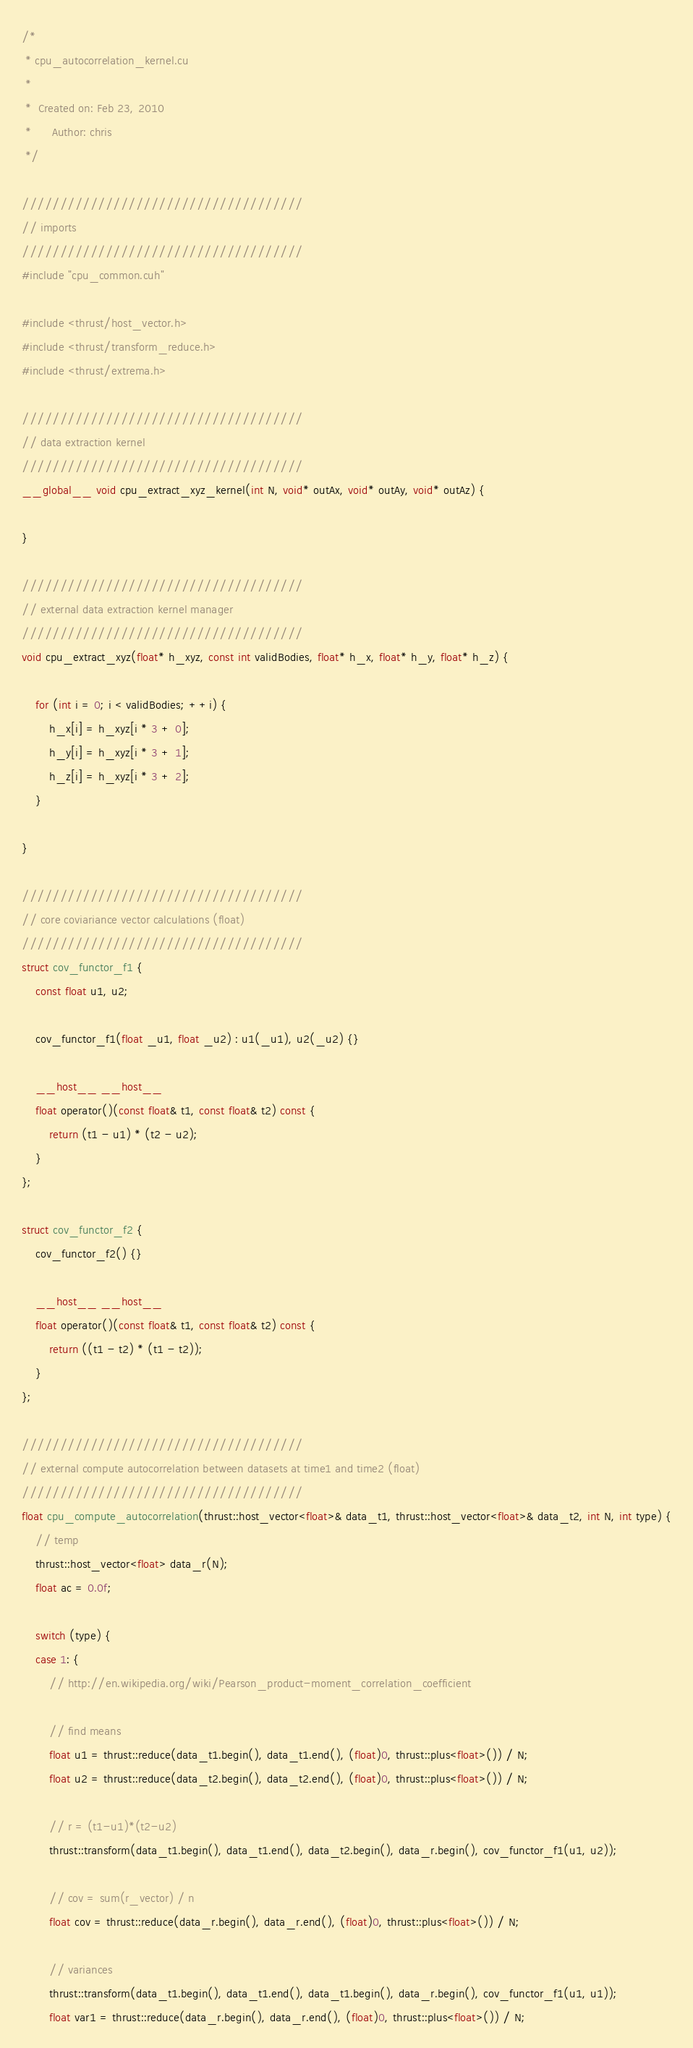Convert code to text. <code><loc_0><loc_0><loc_500><loc_500><_Cuda_>/*
 * cpu_autocorrelation_kernel.cu
 *
 *  Created on: Feb 23, 2010
 *      Author: chris
 */

/////////////////////////////////////
// imports
/////////////////////////////////////
#include "cpu_common.cuh"

#include <thrust/host_vector.h>
#include <thrust/transform_reduce.h>
#include <thrust/extrema.h>

/////////////////////////////////////
// data extraction kernel
/////////////////////////////////////
__global__ void cpu_extract_xyz_kernel(int N, void* outAx, void* outAy, void* outAz) {

}

/////////////////////////////////////
// external data extraction kernel manager
/////////////////////////////////////
void cpu_extract_xyz(float* h_xyz, const int validBodies, float* h_x, float* h_y, float* h_z) {

    for (int i = 0; i < validBodies; ++i) {
        h_x[i] = h_xyz[i * 3 + 0];
        h_y[i] = h_xyz[i * 3 + 1];
        h_z[i] = h_xyz[i * 3 + 2];
    }

}

/////////////////////////////////////
// core coviariance vector calculations (float)
/////////////////////////////////////
struct cov_functor_f1 {
    const float u1, u2;

    cov_functor_f1(float _u1, float _u2) : u1(_u1), u2(_u2) {}

    __host__ __host__
    float operator()(const float& t1, const float& t2) const {
        return (t1 - u1) * (t2 - u2);
    }
};

struct cov_functor_f2 {
    cov_functor_f2() {}

    __host__ __host__
    float operator()(const float& t1, const float& t2) const {
        return ((t1 - t2) * (t1 - t2));
    }
};

/////////////////////////////////////
// external compute autocorrelation between datasets at time1 and time2 (float)
/////////////////////////////////////
float cpu_compute_autocorrelation(thrust::host_vector<float>& data_t1, thrust::host_vector<float>& data_t2, int N, int type) {
    // temp
    thrust::host_vector<float> data_r(N);
    float ac = 0.0f;

    switch (type) {
    case 1: {
        // http://en.wikipedia.org/wiki/Pearson_product-moment_correlation_coefficient

        // find means
        float u1 = thrust::reduce(data_t1.begin(), data_t1.end(), (float)0, thrust::plus<float>()) / N;
        float u2 = thrust::reduce(data_t2.begin(), data_t2.end(), (float)0, thrust::plus<float>()) / N;

        // r = (t1-u1)*(t2-u2)
        thrust::transform(data_t1.begin(), data_t1.end(), data_t2.begin(), data_r.begin(), cov_functor_f1(u1, u2));

        // cov = sum(r_vector) / n
        float cov = thrust::reduce(data_r.begin(), data_r.end(), (float)0, thrust::plus<float>()) / N;

        // variances
        thrust::transform(data_t1.begin(), data_t1.end(), data_t1.begin(), data_r.begin(), cov_functor_f1(u1, u1));
        float var1 = thrust::reduce(data_r.begin(), data_r.end(), (float)0, thrust::plus<float>()) / N;</code> 